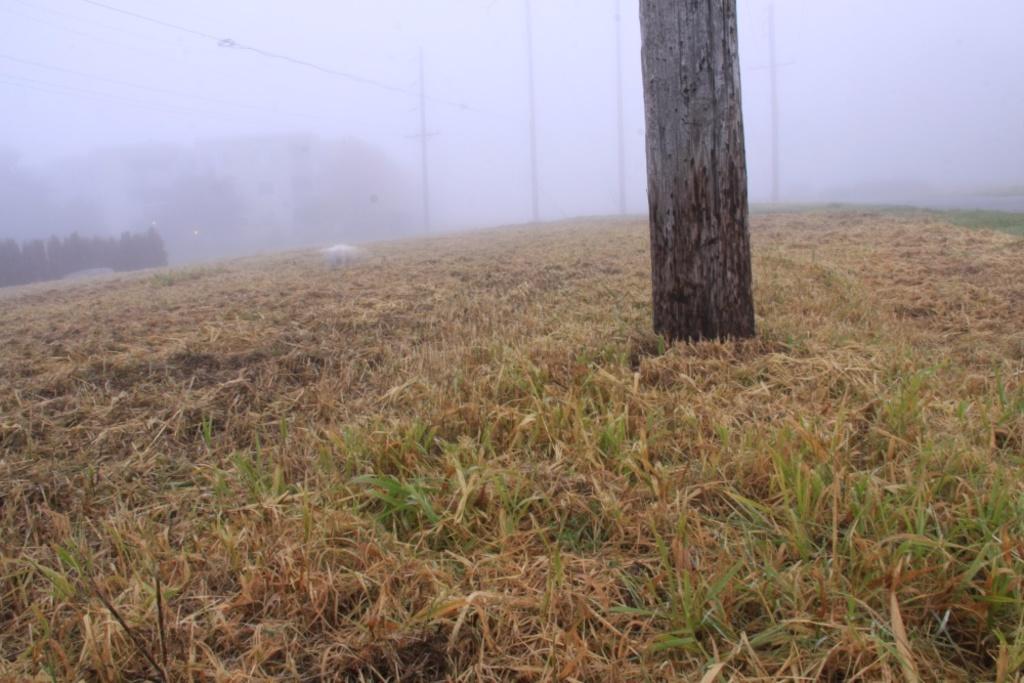How would you summarize this image in a sentence or two? In this image, we can see grass, tree truck. Background there are few poles, wires, trees and fog. 